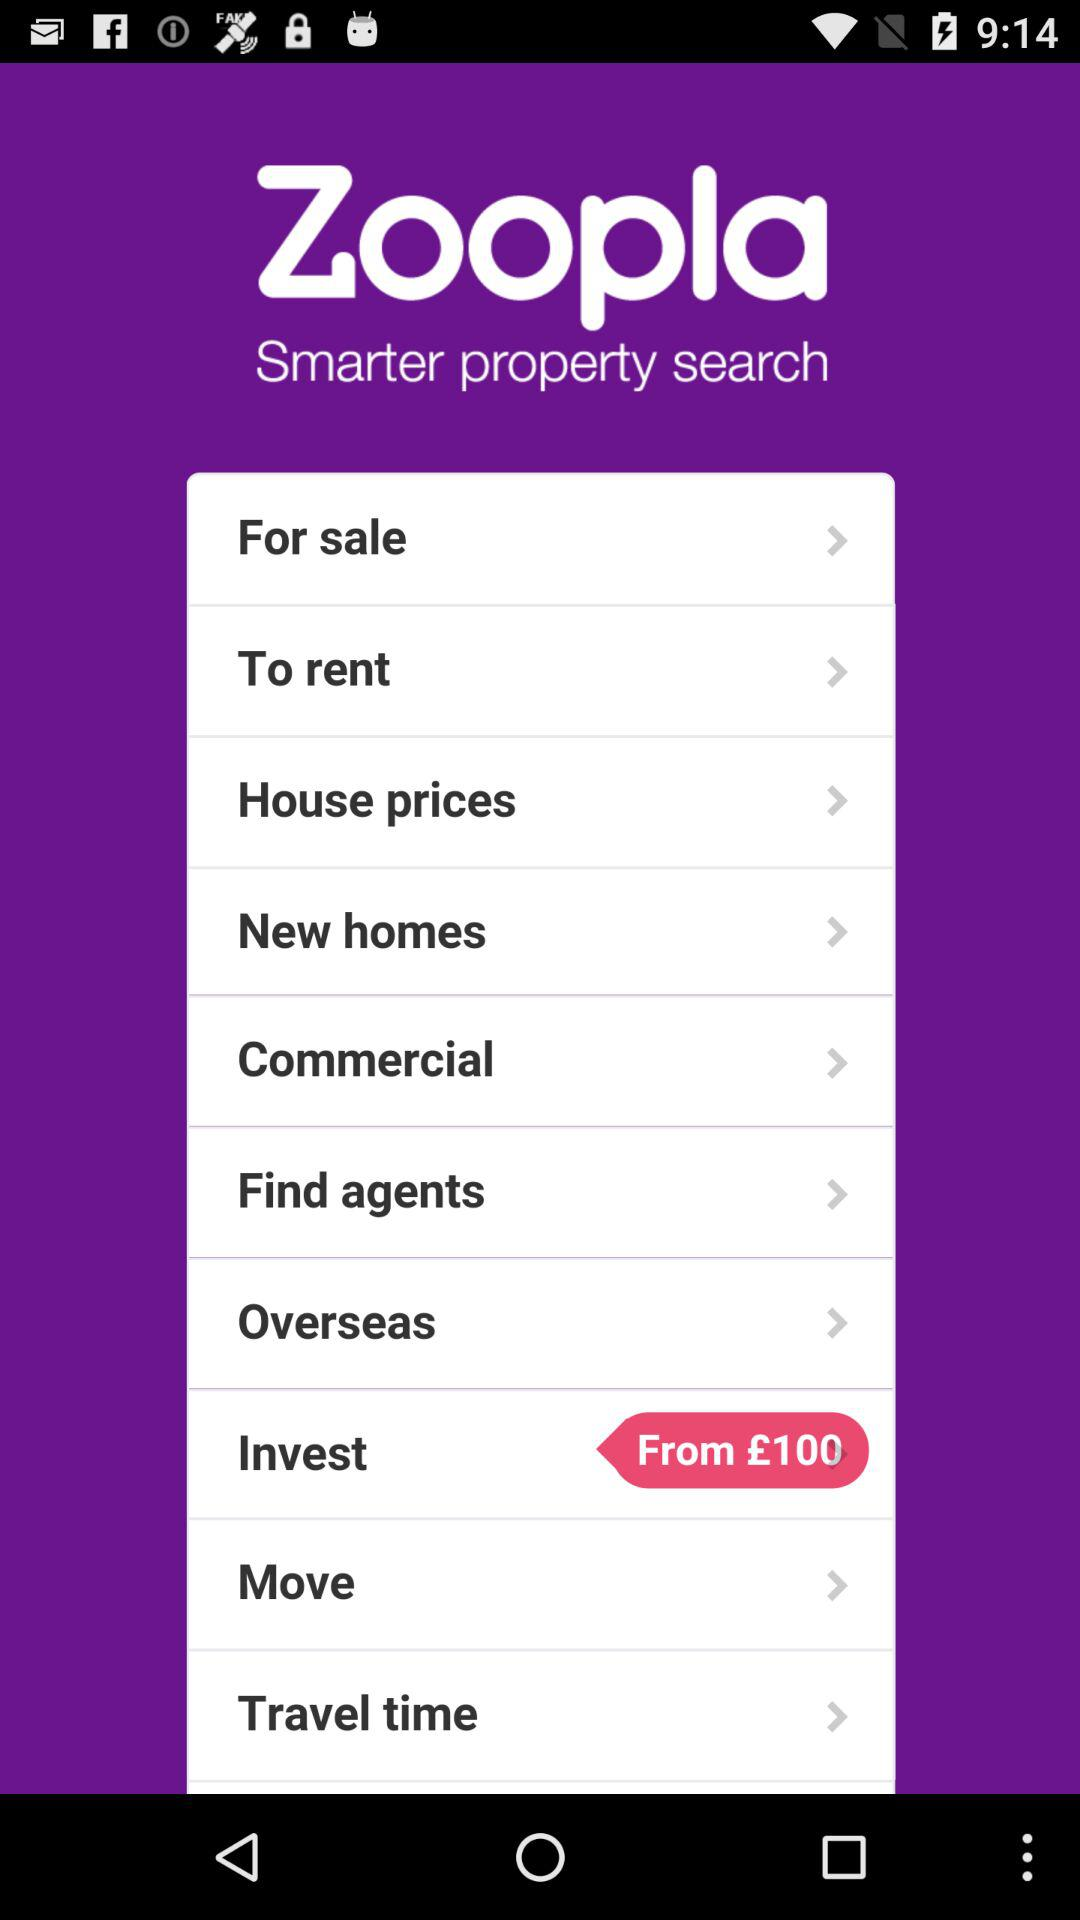How much money can be invested initially? You can invest £100 initially. 